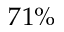<formula> <loc_0><loc_0><loc_500><loc_500>7 1 \%</formula> 